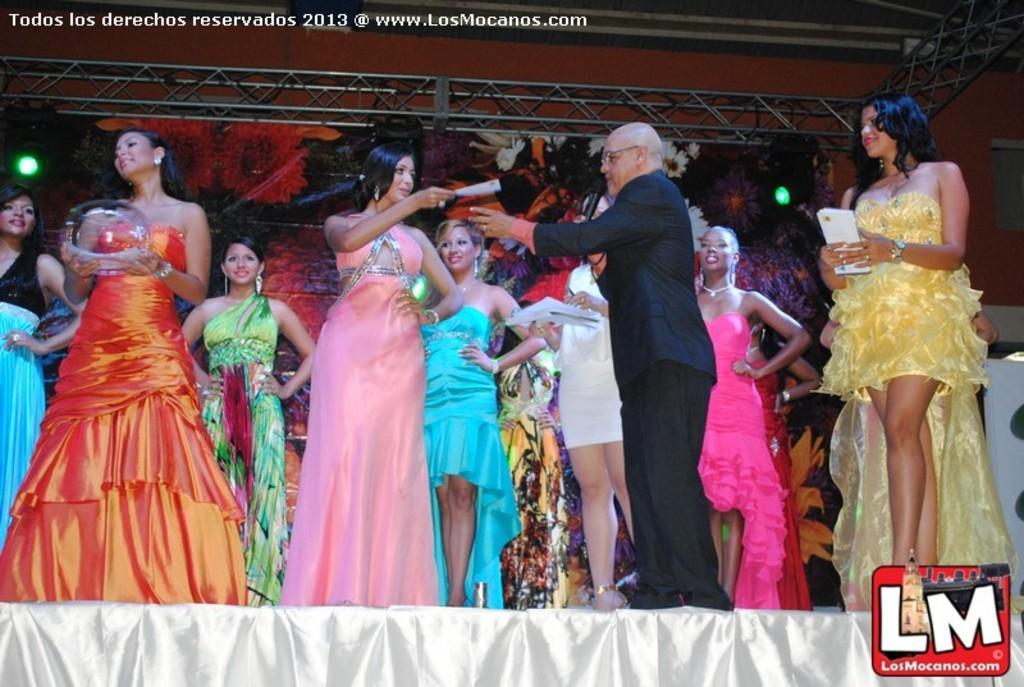Describe this image in one or two sentences. There are people standing on the stage in the foreground, there is a person wearing a black coat, he is holding a mike. There are lights in the background. 